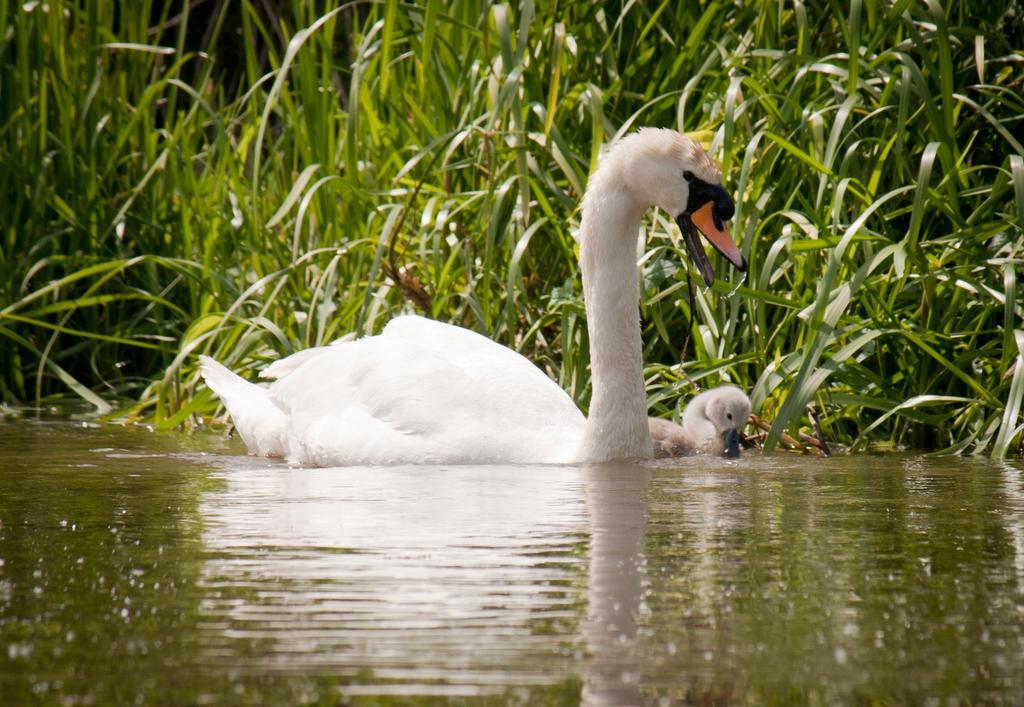Please provide a concise description of this image. In this image in the front there is water and in the center there are birds in the water. In the background there are plants. 